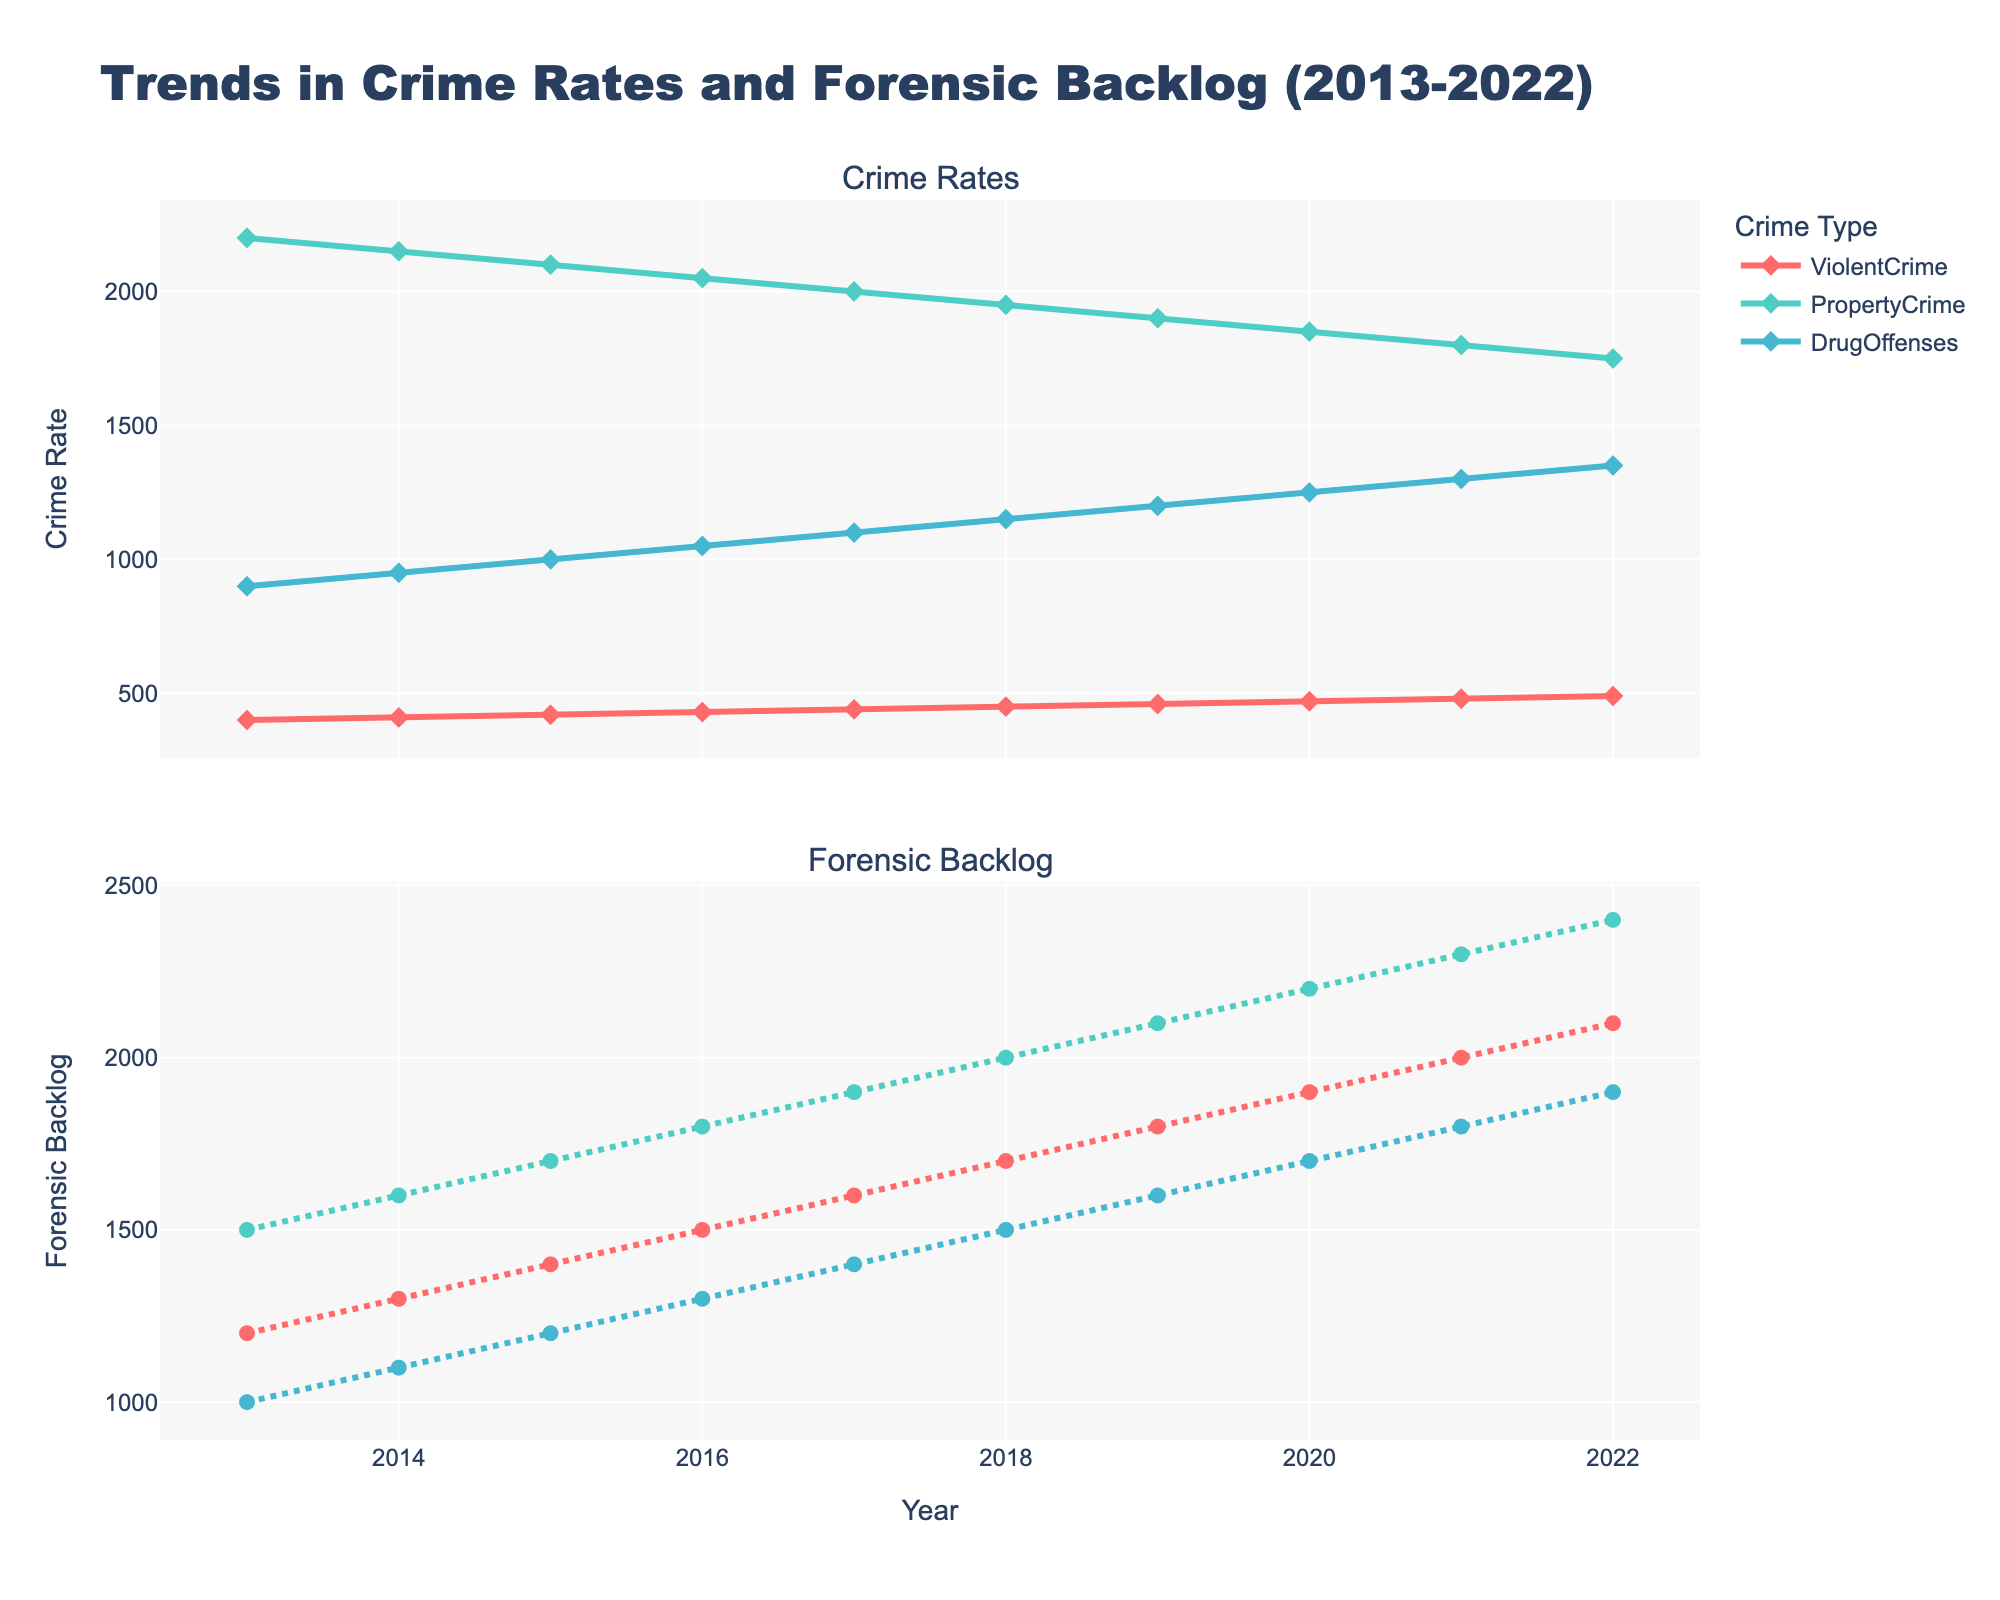What is the title of the plot? The main title is displayed at the top of the figure. It is larger and more prominent than other text.
Answer: Trends in Crime Rates and Forensic Backlog (2013-2022) What is the general trend for violent crime rates from 2013 to 2022? By observing the line representing violent crime rates in the upper subplot, it is seen that the line goes upward consistently over the years.
Answer: Increasing How does the forensic backlog for property crimes in 2013 compare to that in 2022? Find the data points for property crimes on the forensic backlog subplot (bottom). In 2013, the backlog is at 1500, while in 2022 it is at 2400.
Answer: Higher in 2022 Which crime type shows the largest increase in forensic backlog over the years? Calculate the difference from 2013 to 2022 for each crime type by subtracting the 2013 value from the 2022 value in the forensic backlog subplot. The increases are: Violent Crime (900), Property Crime (900), Drug Offenses (900).
Answer: All three types show the same increase In what year did drug offenses have the highest crime rate? Observe the line representing drug offenses on the crime rates subplot (top). The highest point on the plot for drug offenses is in 2022.
Answer: 2022 Did any crime type show a consistent decrease in crime rates over the period? Look at the lines in the crime rates subplot (top) for each crime type. Property crime rates show a consistent decrease from 2013 to 2022.
Answer: Property Crime What is the crime rate value for violent crime in the year 2020? On the crime rates subplot (top), locate the data point for violent crime in 2020. The value is given next to the data point.
Answer: 470 How did the forensic backlog for drug offenses change from 2017 to 2020? Look at the forensic backlog subplot and find the data points for drug offenses in 2017 (1400) and 2020 (1700). Calculate the difference: 1700 - 1400 = 300.
Answer: Increased by 300 Compare the average forensic backlog of drug offenses and property crimes over the decade. Which is higher? Sum the forensic backlog values from 2013 to 2022 for drug offenses (1000+1100+1200+1300+1400+1500+1600+1700+1800+1900=14500) and for property crimes (1500+1600+1700+1800+1900+2000+2100+2200+2300+2400=19500). The average is the total sum divided by 10. Thus, drug offenses average 1450, and property crimes average 1950.
Answer: Property crimes What pattern exists for the property crime rate from 2013-2022? Observe the line for property crime on the crime rates subplot (top). The property crime rate steadily decreases each year from 2200 in 2013 to 1750 in 2022.
Answer: Steadily decreasing If you had to make a prediction, which crime type’s forensic backlog would you expect to increase the most in the next few years? Based on the trend lines in the forensic backlog subplot (bottom), all crime types have shown an increasing trend, but without a clear indication of one increasing more rapidly than the others recently. If past growth rates continue uniformly, no crime type stands out as the most likely to increase more.
Answer: Indeterminate 